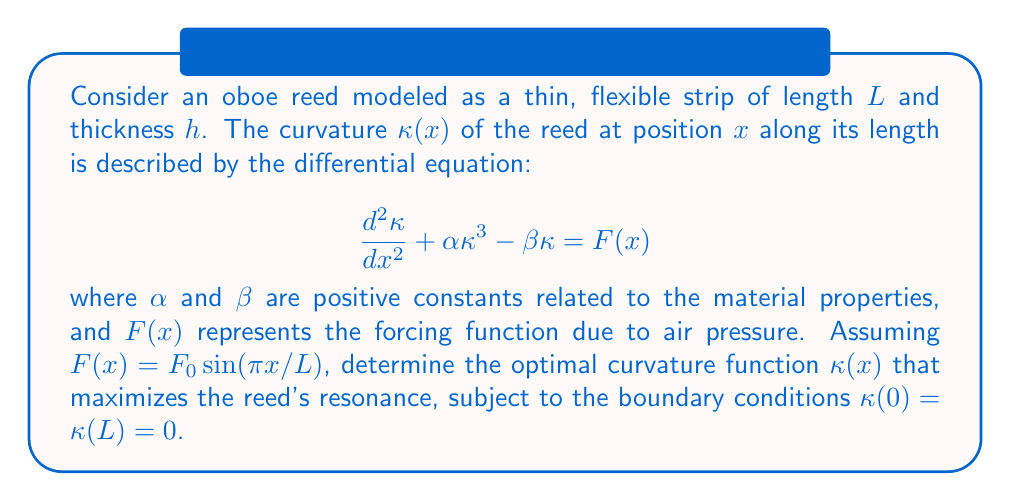Teach me how to tackle this problem. To solve this nonlinear boundary value problem and find the optimal curvature, we'll follow these steps:

1) First, we recognize this as a nonlinear differential equation. Due to its complexity, we'll use a variational approach to find an approximate solution.

2) We can formulate this problem as minimizing the functional:

   $$J[\kappa] = \int_0^L \left[\frac{1}{2}\left(\frac{d\kappa}{dx}\right)^2 + \frac{\alpha}{4}\kappa^4 - \frac{\beta}{2}\kappa^2 - F_0\sin\left(\frac{\pi x}{L}\right)\kappa\right] dx$$

3) The Euler-Lagrange equation for this functional is exactly our original differential equation.

4) To approximate the solution, we can use a Galerkin method with a trial function that satisfies the boundary conditions:

   $$\kappa(x) = A\sin\left(\frac{\pi x}{L}\right)$$

5) Substituting this into our functional and integrating:

   $$J[A] = \frac{\pi^2A^2}{4L} + \frac{3\alpha A^4}{32} - \frac{\beta A^2}{4} - \frac{F_0AL}{2\pi}$$

6) To find the optimal $A$, we differentiate $J[A]$ with respect to $A$ and set it to zero:

   $$\frac{dJ}{dA} = \frac{\pi^2A}{2L} + \frac{3\alpha A^3}{8} - \frac{\beta A}{2} - \frac{F_0L}{2\pi} = 0$$

7) This gives us a cubic equation in $A$. The solution that maximizes resonance is the positive real root of this equation.

8) For specific values of $\alpha$, $\beta$, $F_0$, and $L$, we could solve this numerically. In general, the solution will be of the form:

   $$A = f(\alpha, \beta, F_0, L)$$

   where $f$ is a function that depends on the parameters.

9) Therefore, the optimal curvature function is:

   $$\kappa(x) = f(\alpha, \beta, F_0, L)\sin\left(\frac{\pi x}{L}\right)$$

This solution represents the best approximation to the optimal curvature within our chosen class of functions.
Answer: $\kappa(x) = f(\alpha, \beta, F_0, L)\sin\left(\frac{\pi x}{L}\right)$ 